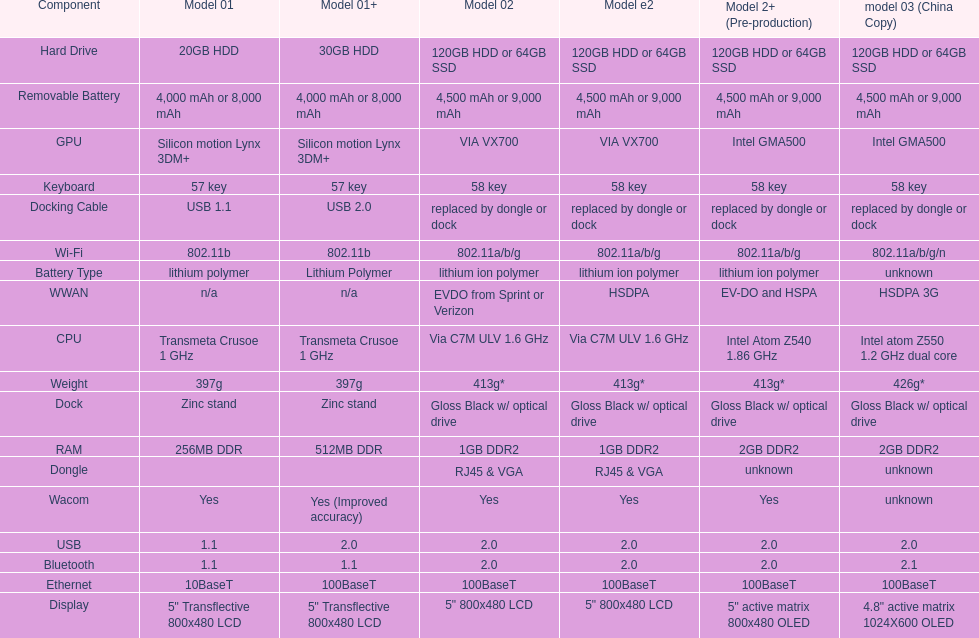The model 2 and the model 2e have what type of cpu? Via C7M ULV 1.6 GHz. 